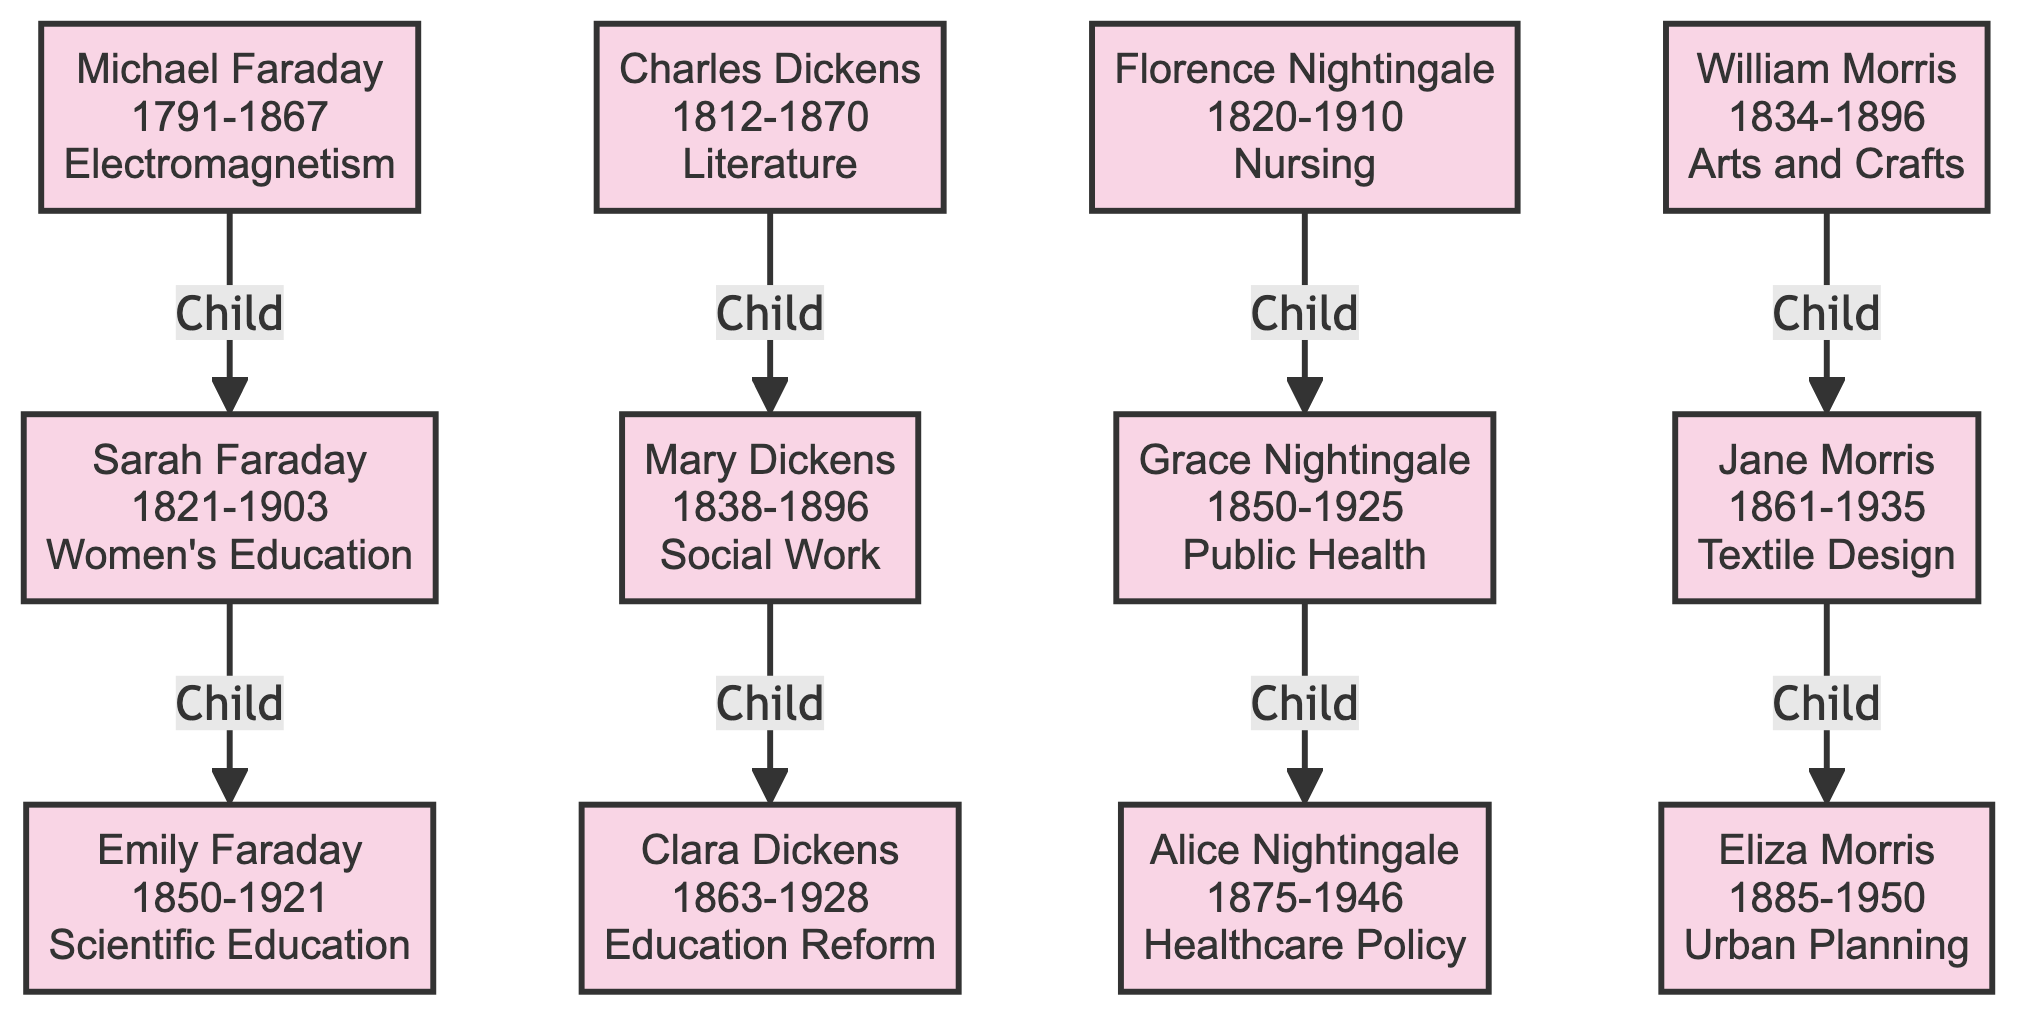What is the contribution of Michael Faraday? The diagram provides information directly associating Michael Faraday with his contribution to "Electromagnetism and Electrochemistry."
Answer: Electromagnetism and Electrochemistry How many children did Florence Nightingale have? By checking the diagram, it shows that Florence Nightingale has one child, Grace Nightingale., which is listed under her node.
Answer: 1 Who is the parent of Clara Dickens? The diagram indicates that Clara Dickens is a child of Mary Dickens, as detailed in the relationship section of the family tree.
Answer: Mary Dickens Which individual was born in 1861? Reviewing the birth years listed in the diagram, Jane Morris is the individual born in 1861, as noted under her node.
Answer: Jane Morris What was the focus of Eliza Morris's work? Looking at the diagram, Eliza Morris is associated with the contribution "Architect and Urban Planner," detailing her work focus.
Answer: Architect and Urban Planner Who is the grandchild of Michael Faraday? To identify the grandchild, follow the lineage from Michael Faraday to Sarah Faraday, and then to her child, Emily Faraday. Thus, Emily Faraday is the grandchild.
Answer: Emily Faraday Which influential Londoner is associated with the Arts and Crafts Movement? The diagram distinctly associates William Morris with the "Arts and Crafts Movement," as highlighted in his contribution section.
Answer: William Morris How many individuals in the diagram are associated with healthcare reforms? By examining the diagram, Florence Nightingale, Grace Nightingale, and Alice Nightingale focus on healthcare reforms, amounting to three individuals.
Answer: 3 What years did Charles Dickens live between? The birth year of Charles Dickens is 1812, and his death year is 1870, as reflected in the information under his node. Therefore, he lived between these two years.
Answer: 1812-1870 